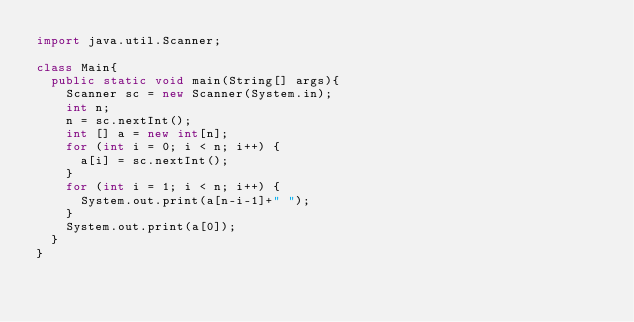Convert code to text. <code><loc_0><loc_0><loc_500><loc_500><_Java_>import java.util.Scanner;

class Main{
  public static void main(String[] args){
    Scanner sc = new Scanner(System.in);
    int n;
    n = sc.nextInt();
    int [] a = new int[n];
    for (int i = 0; i < n; i++) {
      a[i] = sc.nextInt();
    }
    for (int i = 1; i < n; i++) {
      System.out.print(a[n-i-1]+" ");
    }
    System.out.print(a[0]);
  }
}</code> 